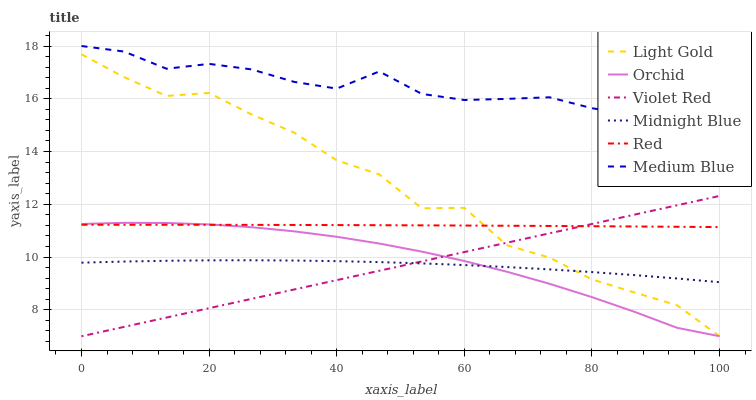Does Violet Red have the minimum area under the curve?
Answer yes or no. Yes. Does Medium Blue have the maximum area under the curve?
Answer yes or no. Yes. Does Midnight Blue have the minimum area under the curve?
Answer yes or no. No. Does Midnight Blue have the maximum area under the curve?
Answer yes or no. No. Is Violet Red the smoothest?
Answer yes or no. Yes. Is Light Gold the roughest?
Answer yes or no. Yes. Is Midnight Blue the smoothest?
Answer yes or no. No. Is Midnight Blue the roughest?
Answer yes or no. No. Does Violet Red have the lowest value?
Answer yes or no. Yes. Does Midnight Blue have the lowest value?
Answer yes or no. No. Does Medium Blue have the highest value?
Answer yes or no. Yes. Does Midnight Blue have the highest value?
Answer yes or no. No. Is Violet Red less than Medium Blue?
Answer yes or no. Yes. Is Red greater than Midnight Blue?
Answer yes or no. Yes. Does Red intersect Violet Red?
Answer yes or no. Yes. Is Red less than Violet Red?
Answer yes or no. No. Is Red greater than Violet Red?
Answer yes or no. No. Does Violet Red intersect Medium Blue?
Answer yes or no. No. 